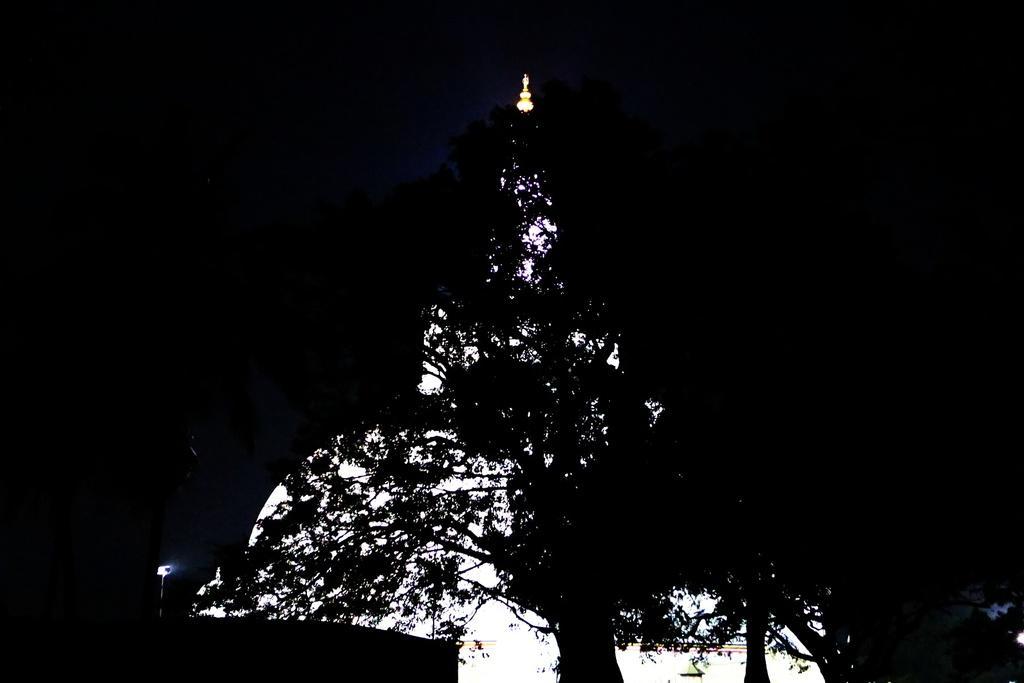Could you give a brief overview of what you see in this image? At the bottom of the picture, we see trees and sky. In the background, it is black in color and this picture might be clicked in the dark. 